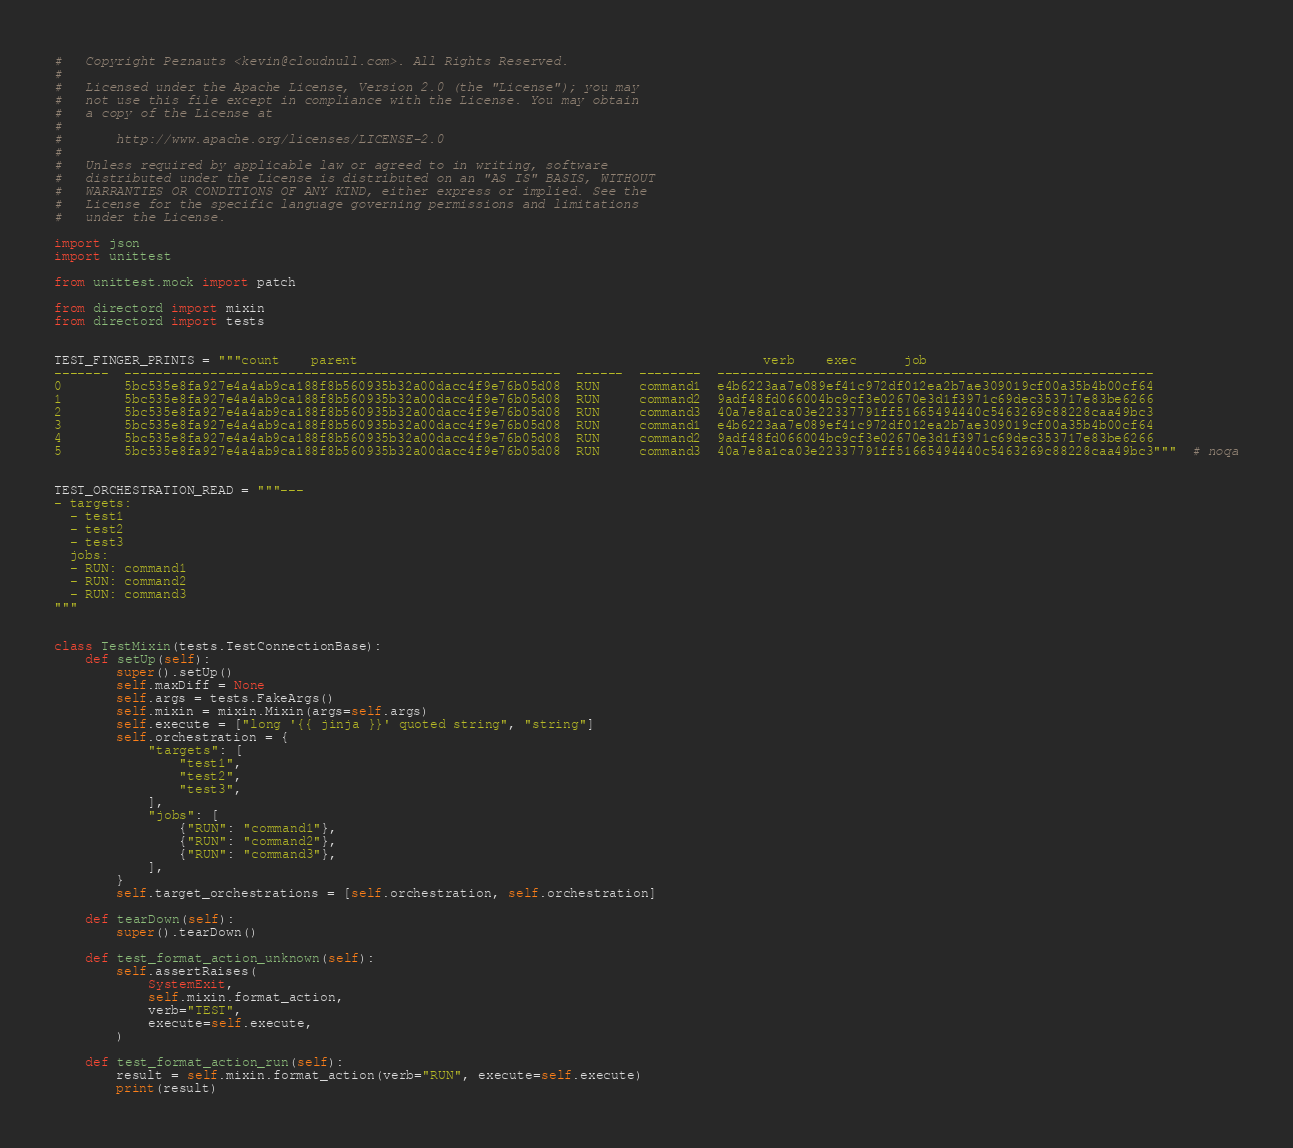Convert code to text. <code><loc_0><loc_0><loc_500><loc_500><_Python_>#   Copyright Peznauts <kevin@cloudnull.com>. All Rights Reserved.
#
#   Licensed under the Apache License, Version 2.0 (the "License"); you may
#   not use this file except in compliance with the License. You may obtain
#   a copy of the License at
#
#       http://www.apache.org/licenses/LICENSE-2.0
#
#   Unless required by applicable law or agreed to in writing, software
#   distributed under the License is distributed on an "AS IS" BASIS, WITHOUT
#   WARRANTIES OR CONDITIONS OF ANY KIND, either express or implied. See the
#   License for the specific language governing permissions and limitations
#   under the License.

import json
import unittest

from unittest.mock import patch

from directord import mixin
from directord import tests


TEST_FINGER_PRINTS = """count    parent                                                    verb    exec      job
-------  --------------------------------------------------------  ------  --------  --------------------------------------------------------
0        5bc535e8fa927e4a4ab9ca188f8b560935b32a00dacc4f9e76b05d08  RUN     command1  e4b6223aa7e089ef41c972df012ea2b7ae309019cf00a35b4b00cf64
1        5bc535e8fa927e4a4ab9ca188f8b560935b32a00dacc4f9e76b05d08  RUN     command2  9adf48fd066004bc9cf3e02670e3d1f3971c69dec353717e83be6266
2        5bc535e8fa927e4a4ab9ca188f8b560935b32a00dacc4f9e76b05d08  RUN     command3  40a7e8a1ca03e22337791ff51665494440c5463269c88228caa49bc3
3        5bc535e8fa927e4a4ab9ca188f8b560935b32a00dacc4f9e76b05d08  RUN     command1  e4b6223aa7e089ef41c972df012ea2b7ae309019cf00a35b4b00cf64
4        5bc535e8fa927e4a4ab9ca188f8b560935b32a00dacc4f9e76b05d08  RUN     command2  9adf48fd066004bc9cf3e02670e3d1f3971c69dec353717e83be6266
5        5bc535e8fa927e4a4ab9ca188f8b560935b32a00dacc4f9e76b05d08  RUN     command3  40a7e8a1ca03e22337791ff51665494440c5463269c88228caa49bc3"""  # noqa


TEST_ORCHESTRATION_READ = """---
- targets:
  - test1
  - test2
  - test3
  jobs:
  - RUN: command1
  - RUN: command2
  - RUN: command3
"""


class TestMixin(tests.TestConnectionBase):
    def setUp(self):
        super().setUp()
        self.maxDiff = None
        self.args = tests.FakeArgs()
        self.mixin = mixin.Mixin(args=self.args)
        self.execute = ["long '{{ jinja }}' quoted string", "string"]
        self.orchestration = {
            "targets": [
                "test1",
                "test2",
                "test3",
            ],
            "jobs": [
                {"RUN": "command1"},
                {"RUN": "command2"},
                {"RUN": "command3"},
            ],
        }
        self.target_orchestrations = [self.orchestration, self.orchestration]

    def tearDown(self):
        super().tearDown()

    def test_format_action_unknown(self):
        self.assertRaises(
            SystemExit,
            self.mixin.format_action,
            verb="TEST",
            execute=self.execute,
        )

    def test_format_action_run(self):
        result = self.mixin.format_action(verb="RUN", execute=self.execute)
        print(result)</code> 